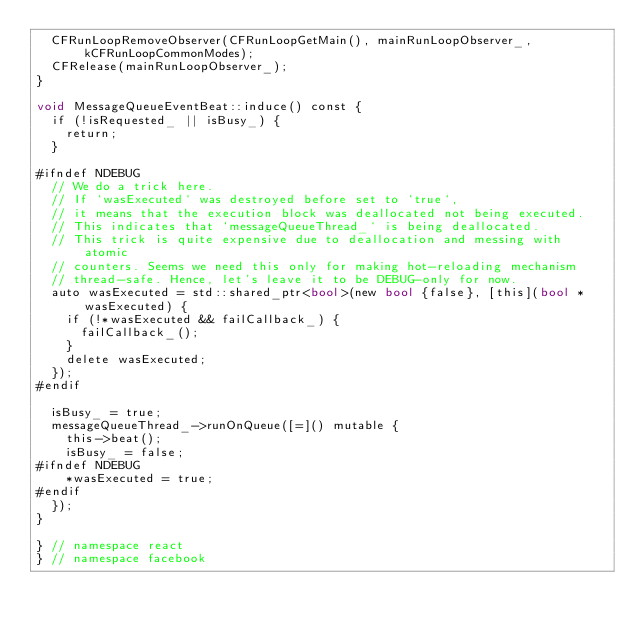<code> <loc_0><loc_0><loc_500><loc_500><_ObjectiveC_>  CFRunLoopRemoveObserver(CFRunLoopGetMain(), mainRunLoopObserver_, kCFRunLoopCommonModes);
  CFRelease(mainRunLoopObserver_);
}

void MessageQueueEventBeat::induce() const {
  if (!isRequested_ || isBusy_) {
    return;
  }

#ifndef NDEBUG
  // We do a trick here.
  // If `wasExecuted` was destroyed before set to `true`,
  // it means that the execution block was deallocated not being executed.
  // This indicates that `messageQueueThread_` is being deallocated.
  // This trick is quite expensive due to deallocation and messing with atomic
  // counters. Seems we need this only for making hot-reloading mechanism
  // thread-safe. Hence, let's leave it to be DEBUG-only for now.
  auto wasExecuted = std::shared_ptr<bool>(new bool {false}, [this](bool *wasExecuted) {
    if (!*wasExecuted && failCallback_) {
      failCallback_();
    }
    delete wasExecuted;
  });
#endif

  isBusy_ = true;
  messageQueueThread_->runOnQueue([=]() mutable {
    this->beat();
    isBusy_ = false;
#ifndef NDEBUG
    *wasExecuted = true;
#endif
  });
}

} // namespace react
} // namespace facebook
</code> 